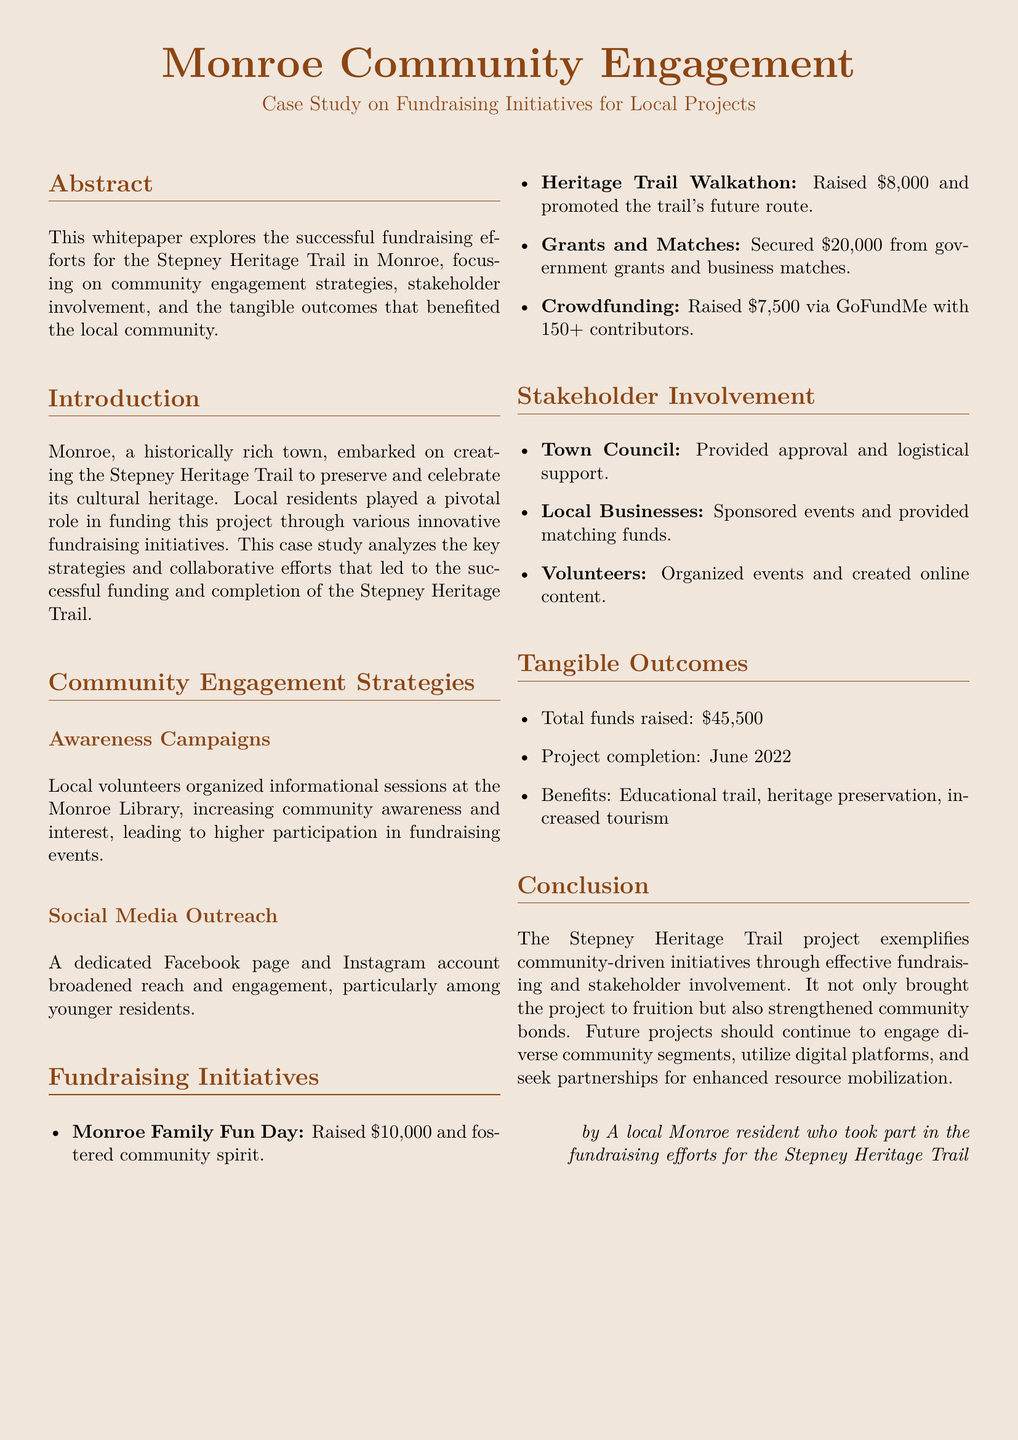What is the total amount raised for the Stepney Heritage Trail? The document states that the total funds raised were $45,500.
Answer: $45,500 When was the project completed? The completion date of the project is mentioned in the document as June 2022.
Answer: June 2022 What fundraising event raised the most money? The Monroe Family Fun Day is noted as raising $10,000, which is the highest amount listed.
Answer: Monroe Family Fun Day What social media platforms were used for outreach? The document mentions a Facebook page and an Instagram account as part of their social media efforts.
Answer: Facebook and Instagram Who provided approval and logistical support for the project? The Town Council is identified in the document as the body that provided approval and support.
Answer: Town Council What was one of the benefits of the Stepney Heritage Trail? The document lists several benefits, including educational trail, heritage preservation, and increased tourism.
Answer: Educational trail How many contributors participated in the crowdfunding effort? According to the document, there were over 150 contributors in the crowdfunding effort.
Answer: 150+ Which initiative raised $8,000? The Heritage Trail Walkathon is noted in the document as raising $8,000.
Answer: Heritage Trail Walkathon What was a key strategy for community engagement? Awareness campaigns are highlighted as a significant strategy for engaging the community.
Answer: Awareness campaigns 